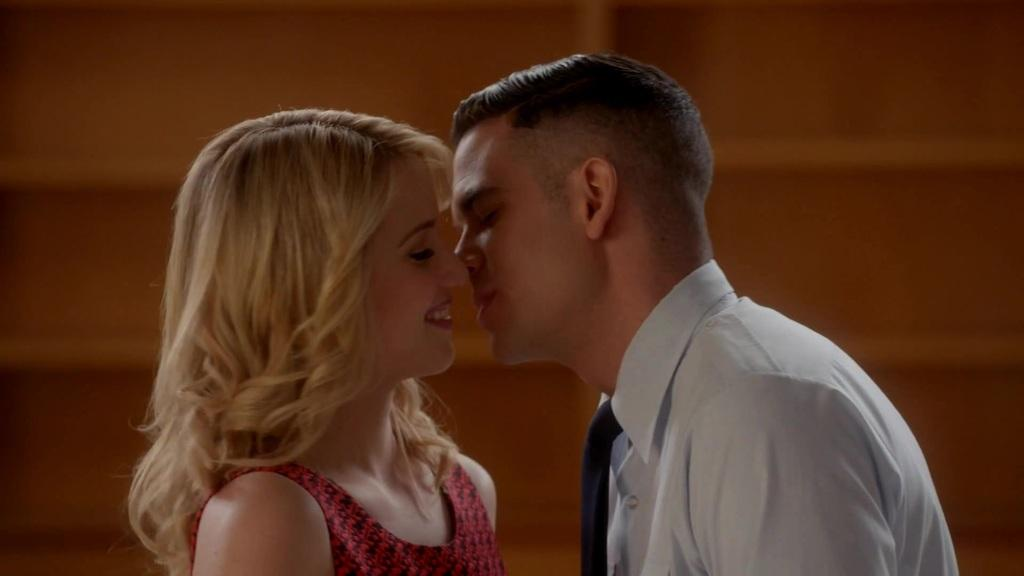What is the woman in the image wearing? The woman is wearing a red dress. What is the man in the image wearing? The man is wearing a white shirt. What are the expressions of the people in the image? The woman is smiling. What is visible in the background of the image? There is a wall visible in the background of the image. How would you describe the quality of the image? The image is blurry. What type of receipt can be seen in the image? There is no receipt present in the image. Is there any coal visible in the image? There is no coal present in the image. 